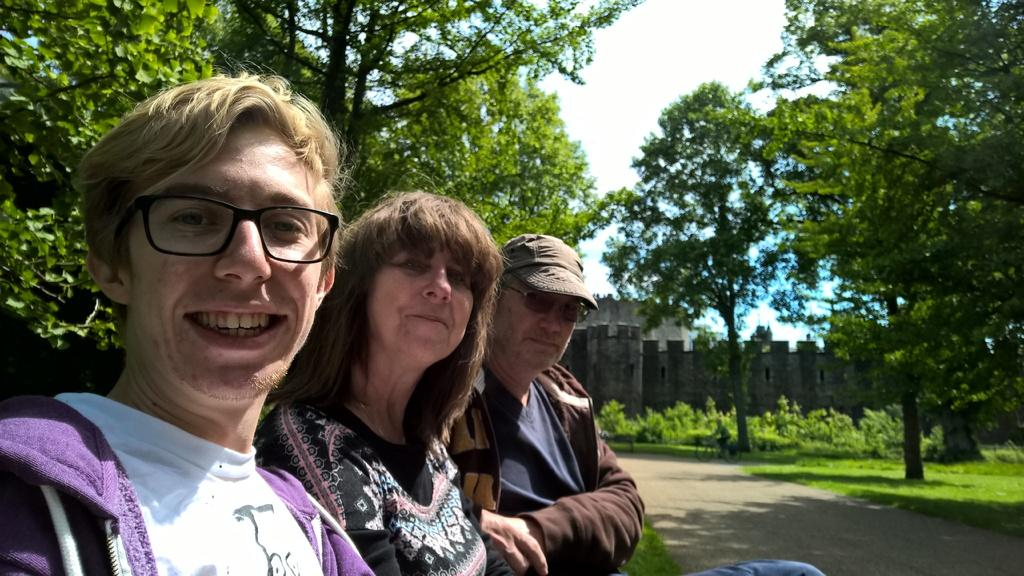How many people are present in the image? There are three persons standing in the image. What type of natural elements can be seen in the image? There are trees and plants in the image. What type of man-made structure is visible in the image? There is a building in the image. What is visible in the background of the image? The sky is visible in the image. What type of linen can be seen draped over the trees in the image? There is no linen draped over the trees in the image; only trees and plants are present. Can you tell me how many owls are perched on the building in the image? There are no owls present in the image; only people, trees, plants, a building, and the sky are visible. 